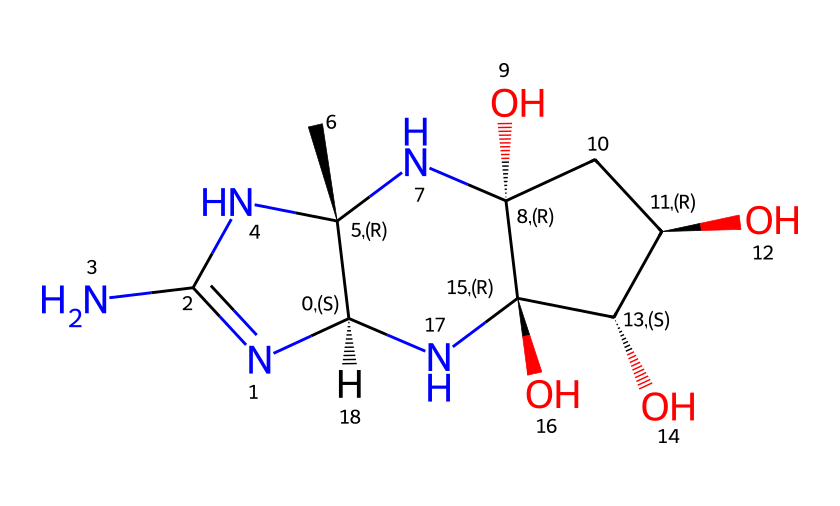how many carbon atoms are in this structure? Count the number of carbon (C) symbols in the SMILES representation. Each capital 'C' represents a carbon atom, and reviewing the structure reveals there are a total of 10 carbon atoms.
Answer: 10 what functional groups are present in this molecule? Examine the structure for identifiable functional groups. The presence of -OH (hydroxyl groups) indicates alcohols, and the nitrogen atoms suggest amines. Together, we can identify hydroxyl and amino functional groups as present in this molecule.
Answer: hydroxyl and amino what is the total number of nitrogen atoms in the structure? Identify each 'N' in the SMILES representation. Counting these reveals there are 3 nitrogen atoms in total.
Answer: 3 which part of the structure suggests it may be toxic to marine life? Algal toxins often contain amine groups which can interact negatively with biological systems. The nitrogen atoms imply the presence of potentially toxic alkaloids that can affect marine life.
Answer: amine groups is this molecule likely to be water-soluble? Water solubility often arises from the presence of polar functional groups like hydroxyls and amines. Given the numerous -OH groups in the structure, it indicates that the molecule is likely to be polar and water-soluble.
Answer: likely water-soluble 